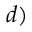Convert formula to latex. <formula><loc_0><loc_0><loc_500><loc_500>d )</formula> 